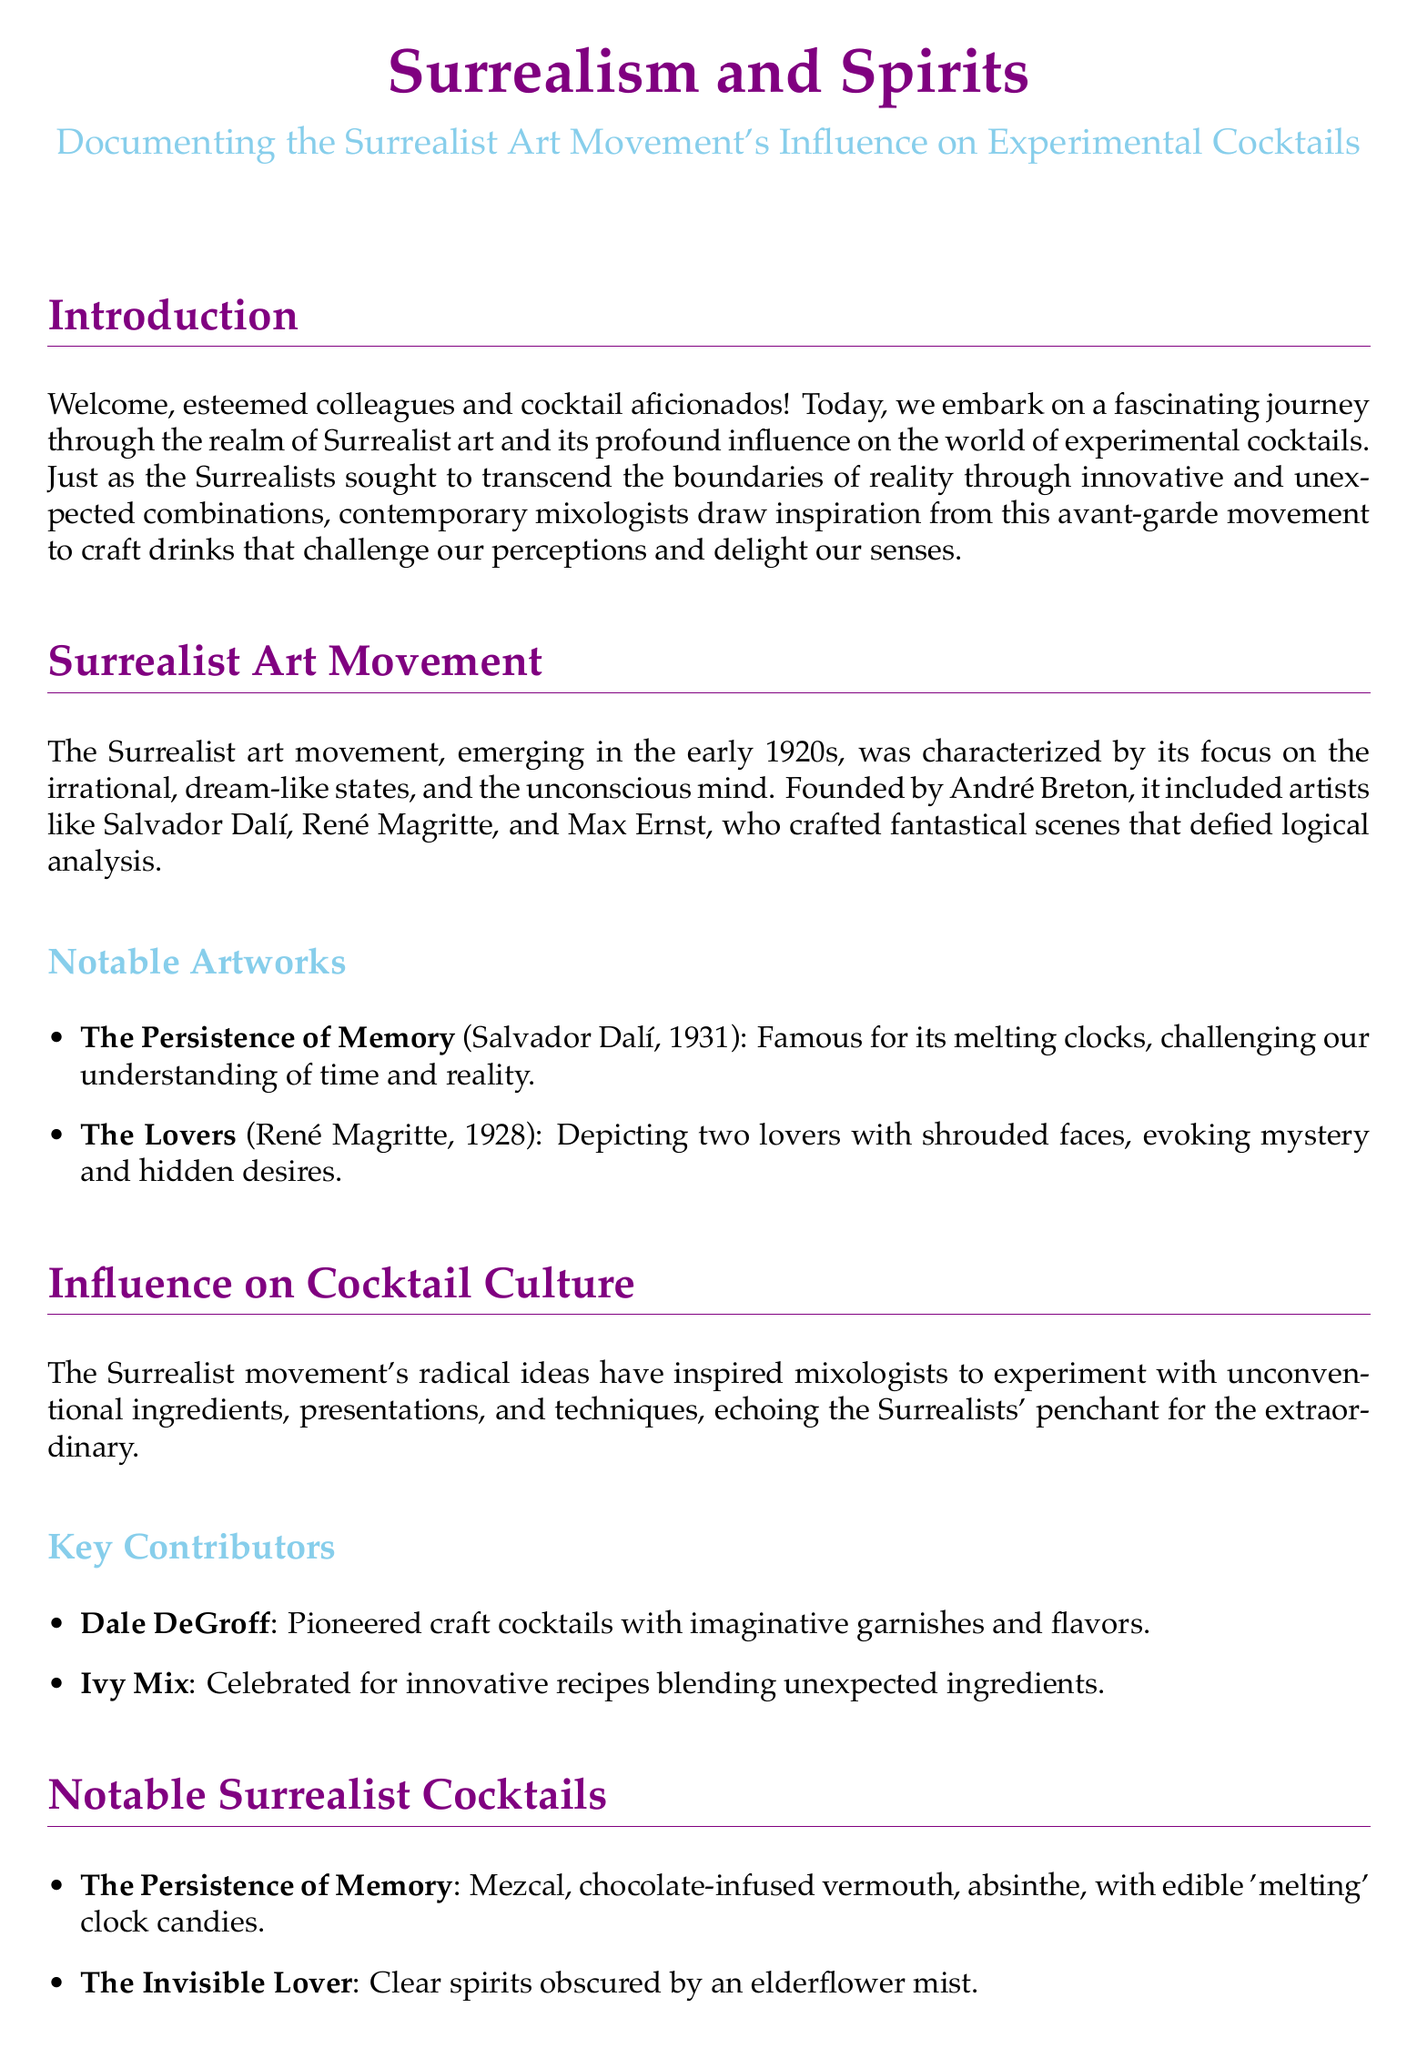What is the title of the document? The title reflects the main theme connecting the Surrealist art movement with cocktail culture.
Answer: Surrealism and Spirits Who founded the Surrealist movement? This person is notable for establishing the principles and manifestos of the Surrealist art movement.
Answer: André Breton In what year did the Surrealist art movement begin? This date signifies the emergence of Surrealism as a distinct art movement in history.
Answer: early 1920s What is the name of the cocktail inspired by Salvador Dalí's art? This cocktail creatively reflects the themes of Dalí's famous painting.
Answer: The Persistence of Memory Which technique is used to create unexpected sensory experiences in cocktails? This technique allows mixologists to innovate and surprise guests through texture.
Answer: Spherification Who is recognized for pioneering craft cocktails with imaginative garnishes? This individual significantly impacted cocktail culture with creative presentations.
Answer: Dale DeGroff What ingredient is featured in the cocktail "The Invisible Lover"? This ingredient plays a central role in the thematic presentation of this cocktail.
Answer: elderflower mist Which notable artwork is referenced in the document? Mentioning an example helps illustrate the Surrealist movement's influence.
Answer: The Lovers How many notable cocktails are listed in the document? The number indicates the variety of drinks inspired by the Surrealist movement.
Answer: two 